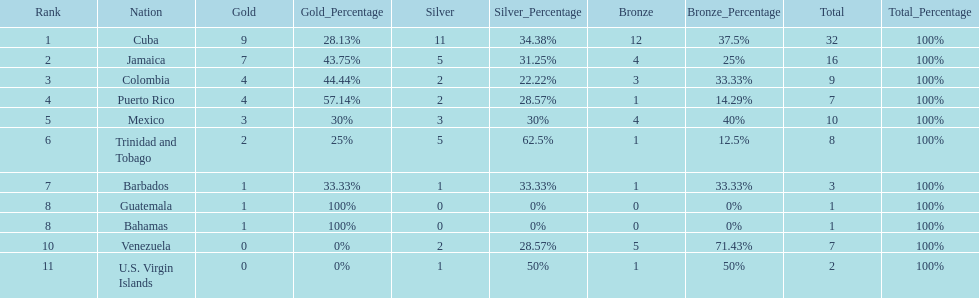What nation has won at least 4 gold medals? Cuba, Jamaica, Colombia, Puerto Rico. Of these countries who has won the least amount of bronze medals? Puerto Rico. 